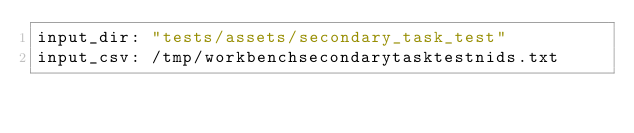Convert code to text. <code><loc_0><loc_0><loc_500><loc_500><_YAML_>input_dir: "tests/assets/secondary_task_test"
input_csv: /tmp/workbenchsecondarytasktestnids.txt
</code> 